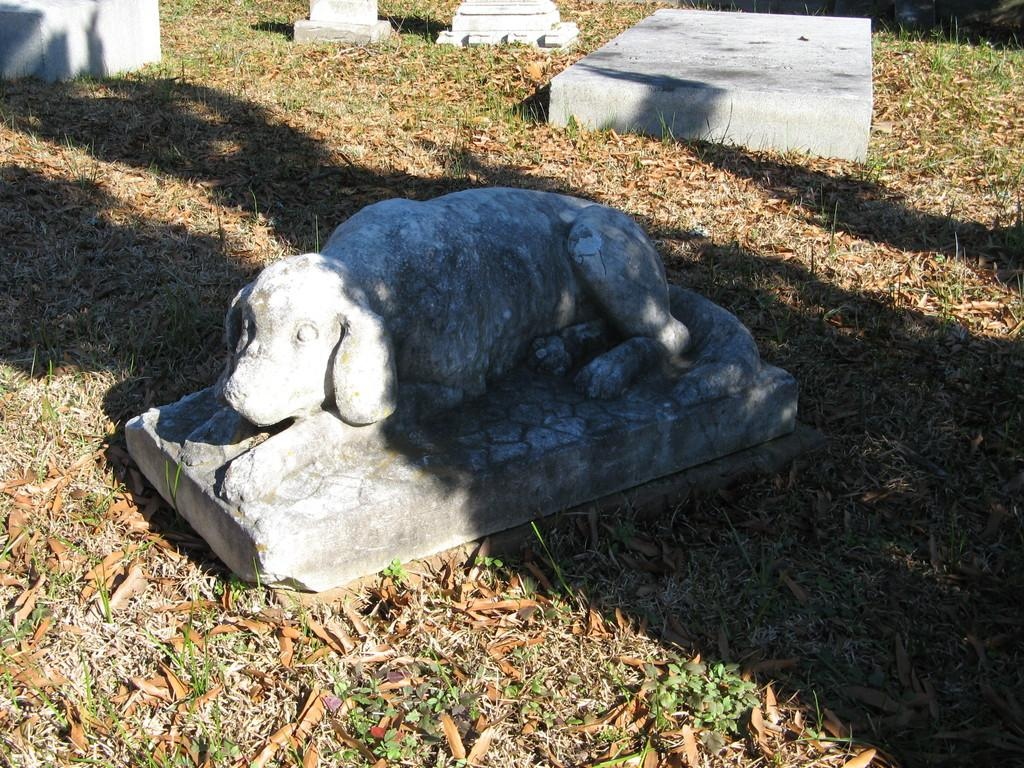What type of sculpture is in the image? There is a dog sculpture in the image. What other objects can be seen in the image? There are concrete blocks in the image. What is visible in the background of the image? Grass and dried leaves are present in the background of the image. What type of approval is the dog sculpture seeking in the image? The dog sculpture is not seeking any approval in the image, as it is a sculpture and not a living being. 